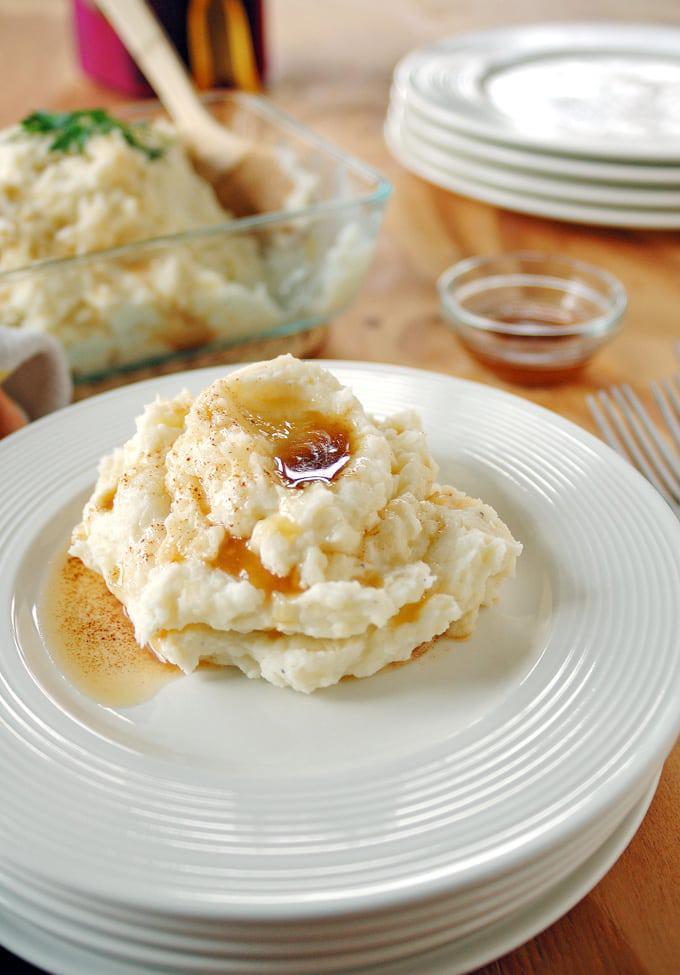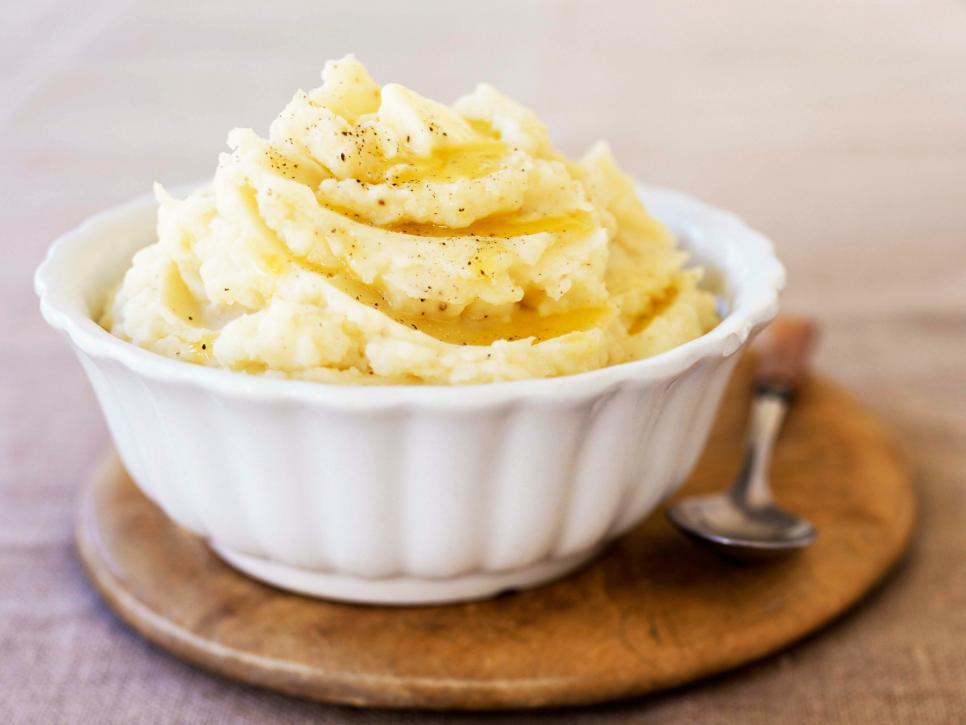The first image is the image on the left, the second image is the image on the right. Assess this claim about the two images: "Every serving of mashed potatoes has a green herb in it, and one serving appears more buttery or yellow than the other.". Correct or not? Answer yes or no. No. 